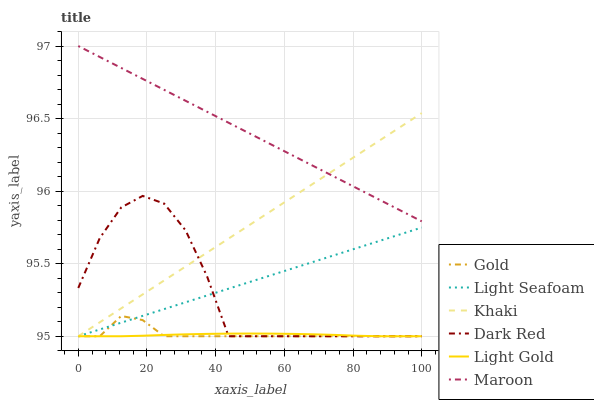Does Light Gold have the minimum area under the curve?
Answer yes or no. Yes. Does Maroon have the maximum area under the curve?
Answer yes or no. Yes. Does Gold have the minimum area under the curve?
Answer yes or no. No. Does Gold have the maximum area under the curve?
Answer yes or no. No. Is Light Seafoam the smoothest?
Answer yes or no. Yes. Is Dark Red the roughest?
Answer yes or no. Yes. Is Gold the smoothest?
Answer yes or no. No. Is Gold the roughest?
Answer yes or no. No. Does Khaki have the lowest value?
Answer yes or no. Yes. Does Maroon have the lowest value?
Answer yes or no. No. Does Maroon have the highest value?
Answer yes or no. Yes. Does Gold have the highest value?
Answer yes or no. No. Is Dark Red less than Maroon?
Answer yes or no. Yes. Is Maroon greater than Light Gold?
Answer yes or no. Yes. Does Khaki intersect Gold?
Answer yes or no. Yes. Is Khaki less than Gold?
Answer yes or no. No. Is Khaki greater than Gold?
Answer yes or no. No. Does Dark Red intersect Maroon?
Answer yes or no. No. 